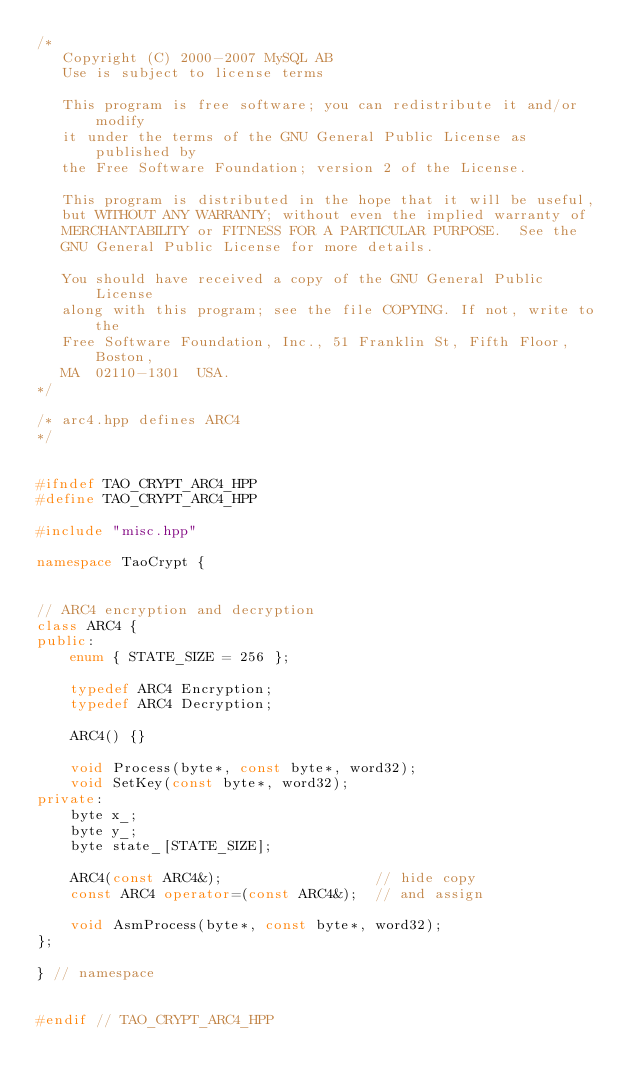Convert code to text. <code><loc_0><loc_0><loc_500><loc_500><_C++_>/*
   Copyright (C) 2000-2007 MySQL AB
   Use is subject to license terms

   This program is free software; you can redistribute it and/or modify
   it under the terms of the GNU General Public License as published by
   the Free Software Foundation; version 2 of the License.

   This program is distributed in the hope that it will be useful,
   but WITHOUT ANY WARRANTY; without even the implied warranty of
   MERCHANTABILITY or FITNESS FOR A PARTICULAR PURPOSE.  See the
   GNU General Public License for more details.

   You should have received a copy of the GNU General Public License
   along with this program; see the file COPYING. If not, write to the
   Free Software Foundation, Inc., 51 Franklin St, Fifth Floor, Boston,
   MA  02110-1301  USA.
*/

/* arc4.hpp defines ARC4
*/


#ifndef TAO_CRYPT_ARC4_HPP
#define TAO_CRYPT_ARC4_HPP

#include "misc.hpp"

namespace TaoCrypt {


// ARC4 encryption and decryption
class ARC4 {
public:
    enum { STATE_SIZE = 256 };

    typedef ARC4 Encryption;
    typedef ARC4 Decryption;

    ARC4() {}

    void Process(byte*, const byte*, word32);
    void SetKey(const byte*, word32);
private:
    byte x_;
    byte y_;
    byte state_[STATE_SIZE];

    ARC4(const ARC4&);                  // hide copy
    const ARC4 operator=(const ARC4&);  // and assign

    void AsmProcess(byte*, const byte*, word32);
};

} // namespace


#endif // TAO_CRYPT_ARC4_HPP

</code> 